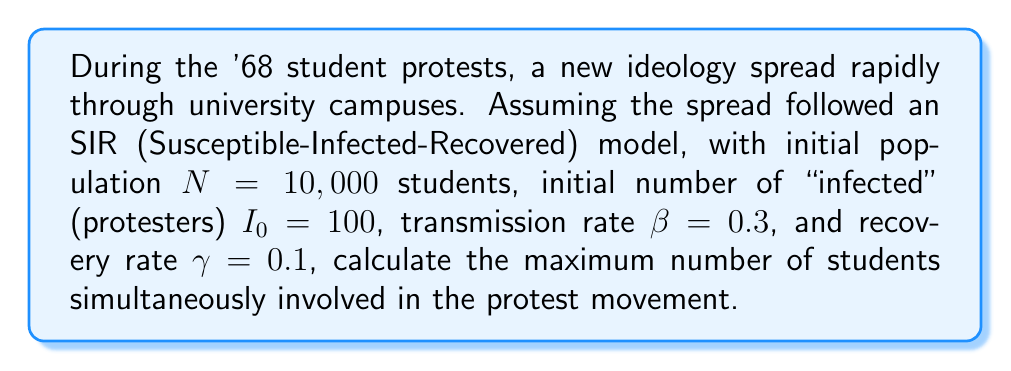Give your solution to this math problem. To solve this problem, we'll use the SIR model equations and find the peak of the "infected" (protesters) curve. The SIR model is described by the following differential equations:

$$\frac{dS}{dt} = -\beta SI/N$$
$$\frac{dI}{dt} = \beta SI/N - \gamma I$$
$$\frac{dR}{dt} = \gamma I$$

Where:
$S$ = Susceptible population
$I$ = Infected (protesting) population
$R$ = Recovered (no longer protesting) population
$N$ = Total population
$\beta$ = Transmission rate
$\gamma$ = Recovery rate

The peak of the infection occurs when $\frac{dI}{dt} = 0$. At this point:

$$\beta SI/N - \gamma I = 0$$
$$\beta S/N = \gamma$$
$$S = \gamma N / \beta$$

Substituting the given values:

$$S = (0.1 * 10,000) / 0.3 = 3,333.33$$

The total population $N$ is constant, so:

$$N = S + I + R$$
$$10,000 = 3,333.33 + I_{max} + R$$

At the peak, we can calculate $R$ using the initial conditions and the fact that $S + I + R = N$:

$$R = N - S - I_0 = 10,000 - 3,333.33 - 100 = 6,566.67$$

Therefore:

$$10,000 = 3,333.33 + I_{max} + 6,566.67$$
$$I_{max} = 10,000 - 3,333.33 - 6,566.67 = 100$$

The maximum number of students simultaneously involved in the protest movement is 100.
Answer: 100 students 